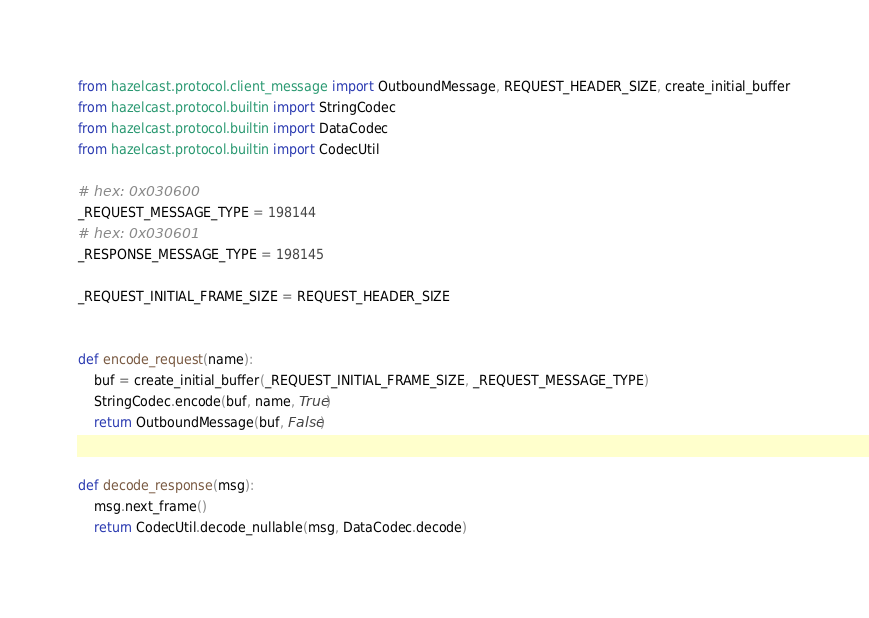<code> <loc_0><loc_0><loc_500><loc_500><_Python_>from hazelcast.protocol.client_message import OutboundMessage, REQUEST_HEADER_SIZE, create_initial_buffer
from hazelcast.protocol.builtin import StringCodec
from hazelcast.protocol.builtin import DataCodec
from hazelcast.protocol.builtin import CodecUtil

# hex: 0x030600
_REQUEST_MESSAGE_TYPE = 198144
# hex: 0x030601
_RESPONSE_MESSAGE_TYPE = 198145

_REQUEST_INITIAL_FRAME_SIZE = REQUEST_HEADER_SIZE


def encode_request(name):
    buf = create_initial_buffer(_REQUEST_INITIAL_FRAME_SIZE, _REQUEST_MESSAGE_TYPE)
    StringCodec.encode(buf, name, True)
    return OutboundMessage(buf, False)


def decode_response(msg):
    msg.next_frame()
    return CodecUtil.decode_nullable(msg, DataCodec.decode)
</code> 